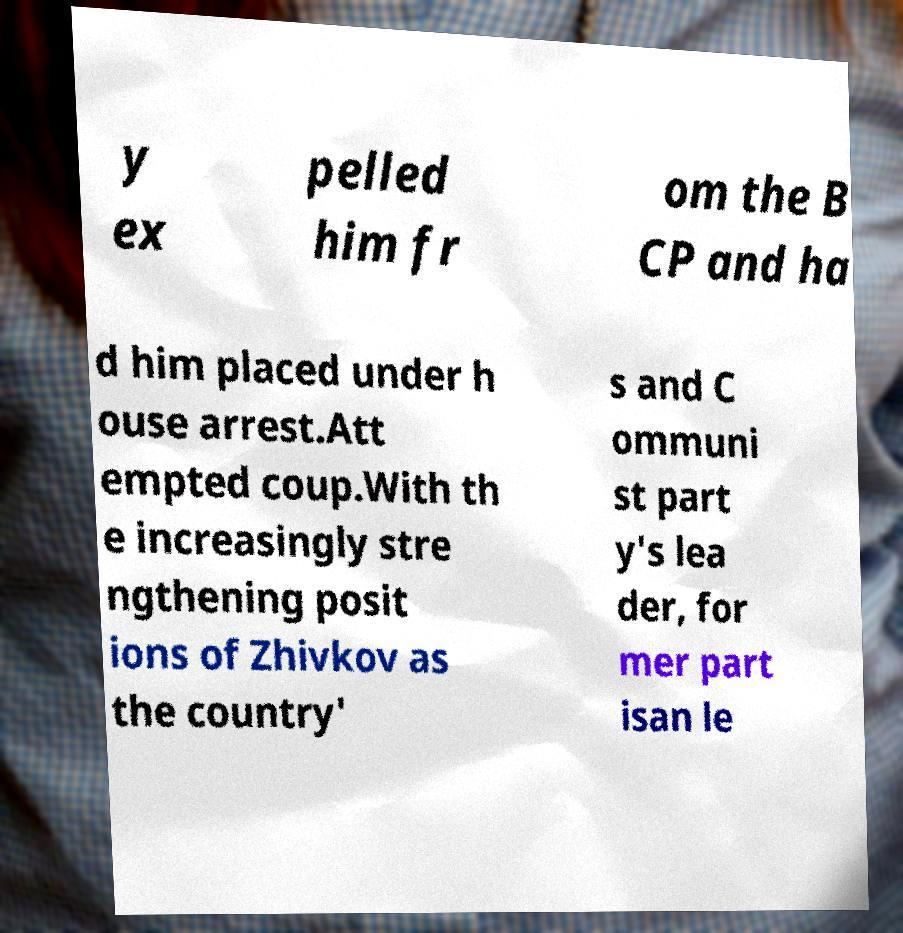Could you assist in decoding the text presented in this image and type it out clearly? y ex pelled him fr om the B CP and ha d him placed under h ouse arrest.Att empted coup.With th e increasingly stre ngthening posit ions of Zhivkov as the country' s and C ommuni st part y's lea der, for mer part isan le 